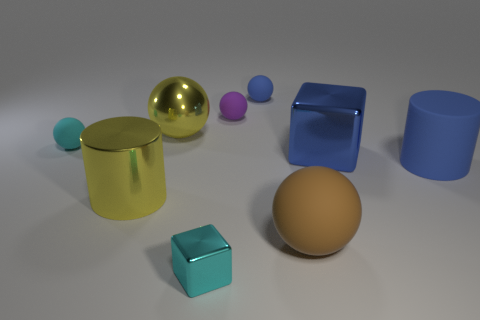There is a rubber ball that is the same color as the tiny metallic cube; what size is it?
Your response must be concise. Small. What number of other objects are the same color as the large metallic block?
Your answer should be compact. 2. Is the number of large blue matte cylinders on the left side of the cyan shiny thing less than the number of tiny things?
Offer a terse response. Yes. Are there any gray cylinders that have the same size as the cyan ball?
Give a very brief answer. No. There is a metallic cylinder; is its color the same as the large thing that is behind the large blue metallic object?
Offer a very short reply. Yes. There is a large cylinder on the right side of the small purple ball; how many tiny purple matte objects are to the right of it?
Provide a succinct answer. 0. What color is the cylinder that is on the right side of the ball that is on the right side of the tiny blue object?
Offer a very short reply. Blue. There is a big object that is to the right of the large brown rubber thing and in front of the large blue cube; what is it made of?
Provide a short and direct response. Rubber. Are there any gray shiny things that have the same shape as the purple rubber object?
Make the answer very short. No. There is a blue matte object that is on the left side of the big brown object; is it the same shape as the big blue metal object?
Provide a short and direct response. No. 